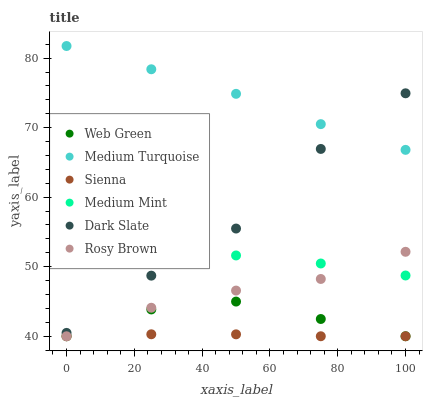Does Sienna have the minimum area under the curve?
Answer yes or no. Yes. Does Medium Turquoise have the maximum area under the curve?
Answer yes or no. Yes. Does Rosy Brown have the minimum area under the curve?
Answer yes or no. No. Does Rosy Brown have the maximum area under the curve?
Answer yes or no. No. Is Sienna the smoothest?
Answer yes or no. Yes. Is Dark Slate the roughest?
Answer yes or no. Yes. Is Rosy Brown the smoothest?
Answer yes or no. No. Is Rosy Brown the roughest?
Answer yes or no. No. Does Rosy Brown have the lowest value?
Answer yes or no. Yes. Does Dark Slate have the lowest value?
Answer yes or no. No. Does Medium Turquoise have the highest value?
Answer yes or no. Yes. Does Rosy Brown have the highest value?
Answer yes or no. No. Is Sienna less than Dark Slate?
Answer yes or no. Yes. Is Medium Turquoise greater than Web Green?
Answer yes or no. Yes. Does Medium Turquoise intersect Dark Slate?
Answer yes or no. Yes. Is Medium Turquoise less than Dark Slate?
Answer yes or no. No. Is Medium Turquoise greater than Dark Slate?
Answer yes or no. No. Does Sienna intersect Dark Slate?
Answer yes or no. No. 